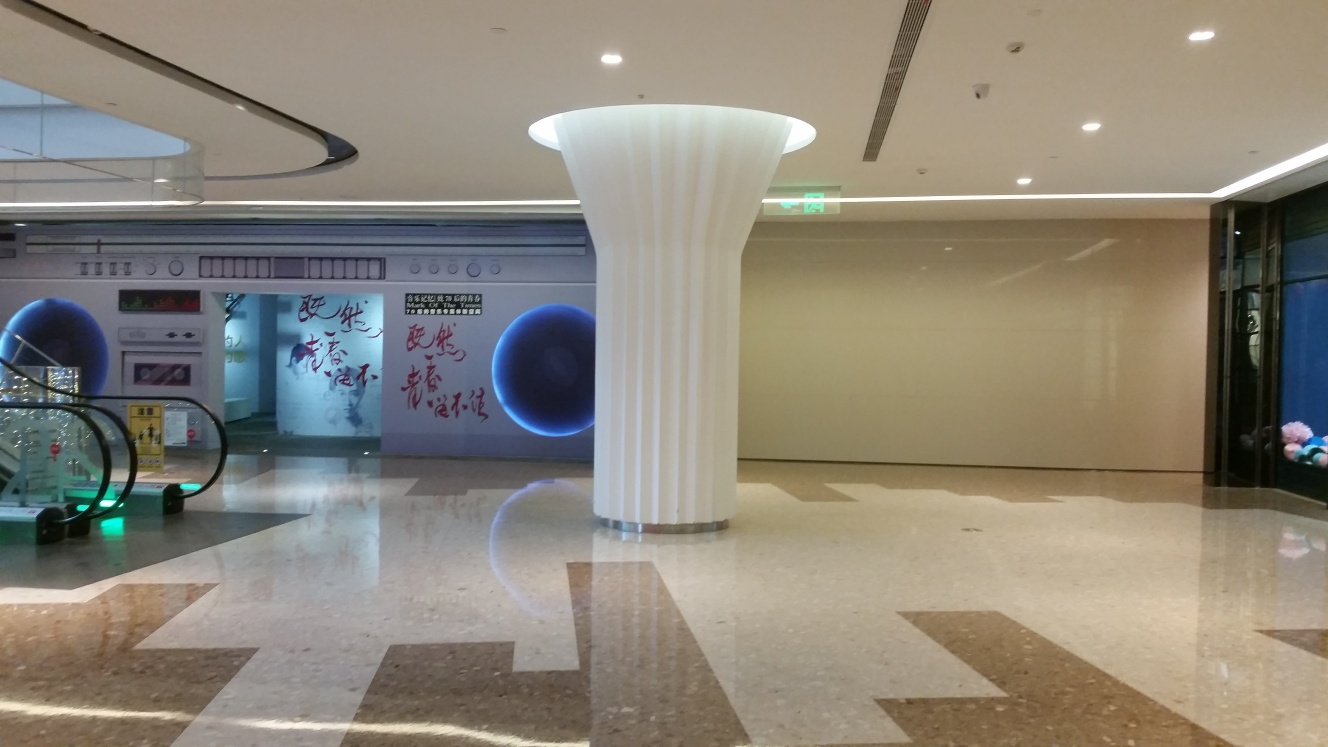Is the image too dark? The image is moderately lit with ample ambient light illuminating the indoor space, highlighting the floor's reflective surface and the unique pillar structure in the center. 